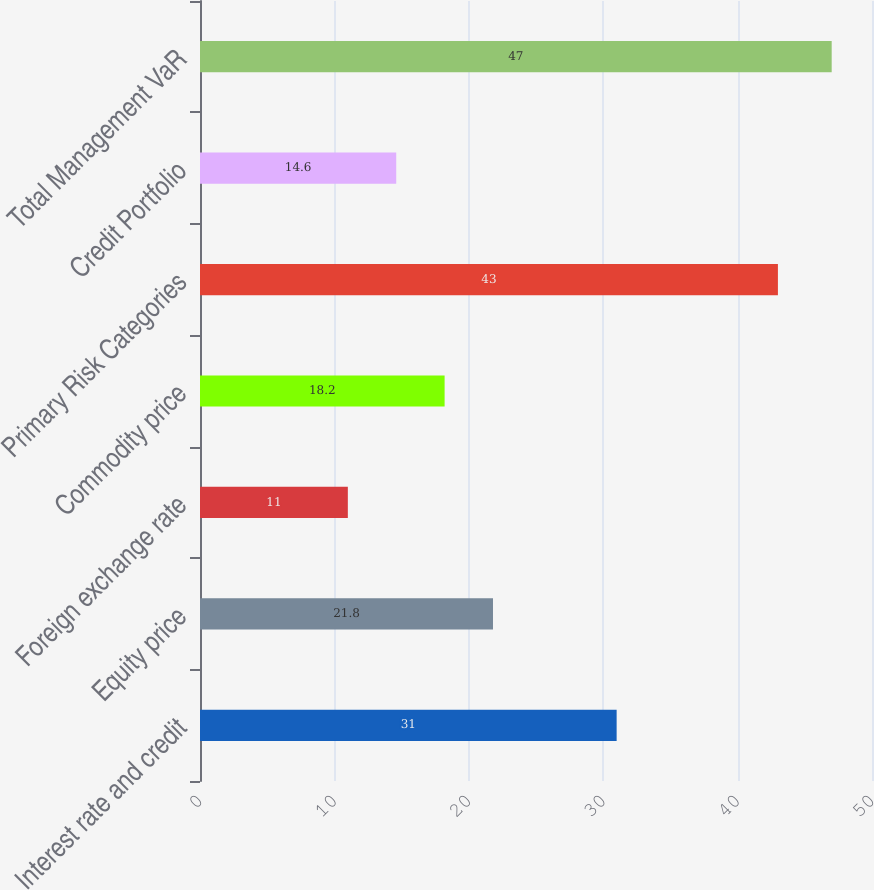Convert chart to OTSL. <chart><loc_0><loc_0><loc_500><loc_500><bar_chart><fcel>Interest rate and credit<fcel>Equity price<fcel>Foreign exchange rate<fcel>Commodity price<fcel>Primary Risk Categories<fcel>Credit Portfolio<fcel>Total Management VaR<nl><fcel>31<fcel>21.8<fcel>11<fcel>18.2<fcel>43<fcel>14.6<fcel>47<nl></chart> 